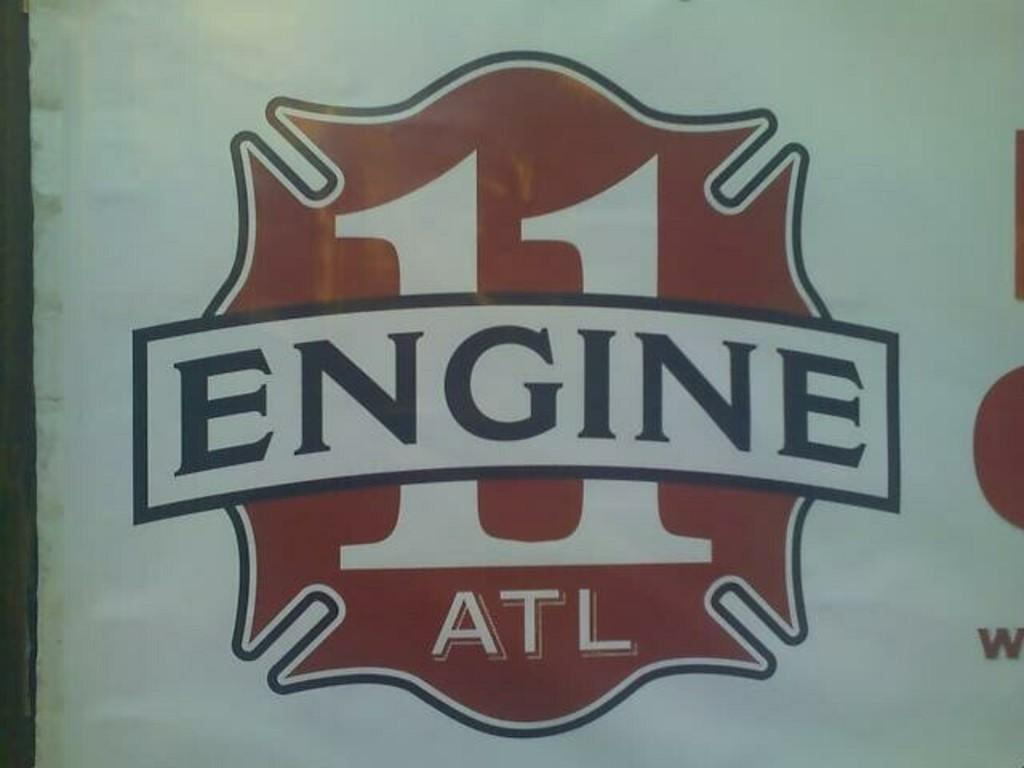Provide a one-sentence caption for the provided image. A red, white, and black design for Engine 11 ATL. 